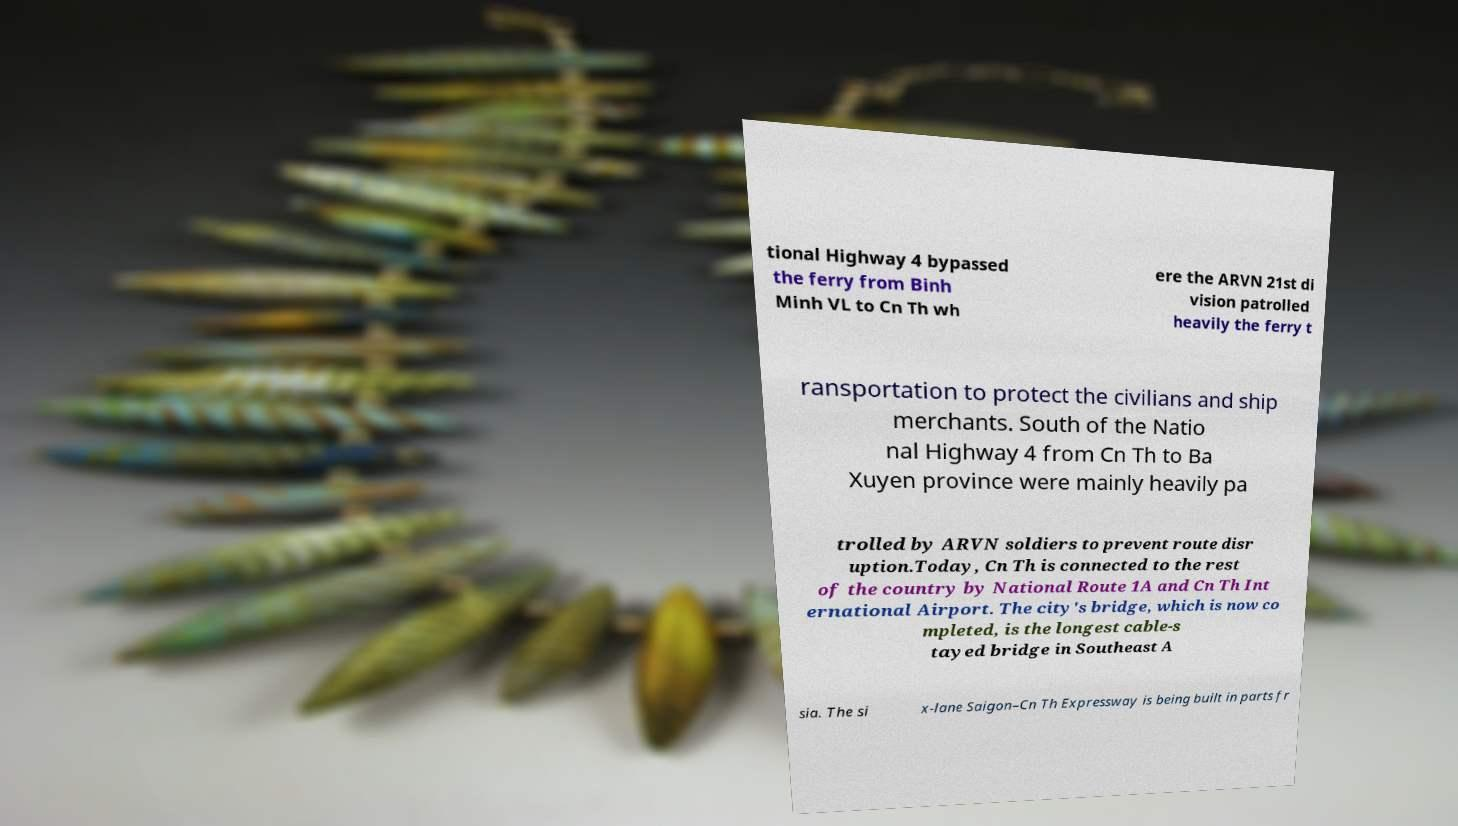Can you read and provide the text displayed in the image?This photo seems to have some interesting text. Can you extract and type it out for me? tional Highway 4 bypassed the ferry from Binh Minh VL to Cn Th wh ere the ARVN 21st di vision patrolled heavily the ferry t ransportation to protect the civilians and ship merchants. South of the Natio nal Highway 4 from Cn Th to Ba Xuyen province were mainly heavily pa trolled by ARVN soldiers to prevent route disr uption.Today, Cn Th is connected to the rest of the country by National Route 1A and Cn Th Int ernational Airport. The city's bridge, which is now co mpleted, is the longest cable-s tayed bridge in Southeast A sia. The si x-lane Saigon–Cn Th Expressway is being built in parts fr 